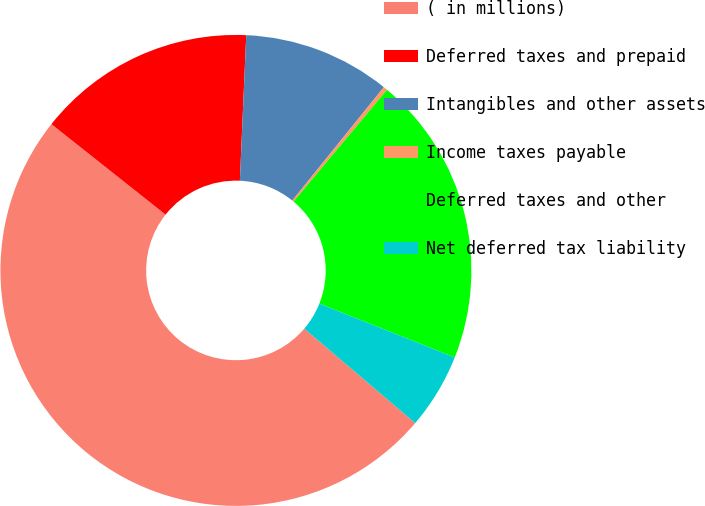Convert chart to OTSL. <chart><loc_0><loc_0><loc_500><loc_500><pie_chart><fcel>( in millions)<fcel>Deferred taxes and prepaid<fcel>Intangibles and other assets<fcel>Income taxes payable<fcel>Deferred taxes and other<fcel>Net deferred tax liability<nl><fcel>49.44%<fcel>15.03%<fcel>10.11%<fcel>0.28%<fcel>19.94%<fcel>5.2%<nl></chart> 